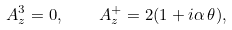<formula> <loc_0><loc_0><loc_500><loc_500>A _ { z } ^ { 3 } = 0 , \quad A _ { z } ^ { + } = 2 ( 1 + i \alpha \, \theta ) ,</formula> 